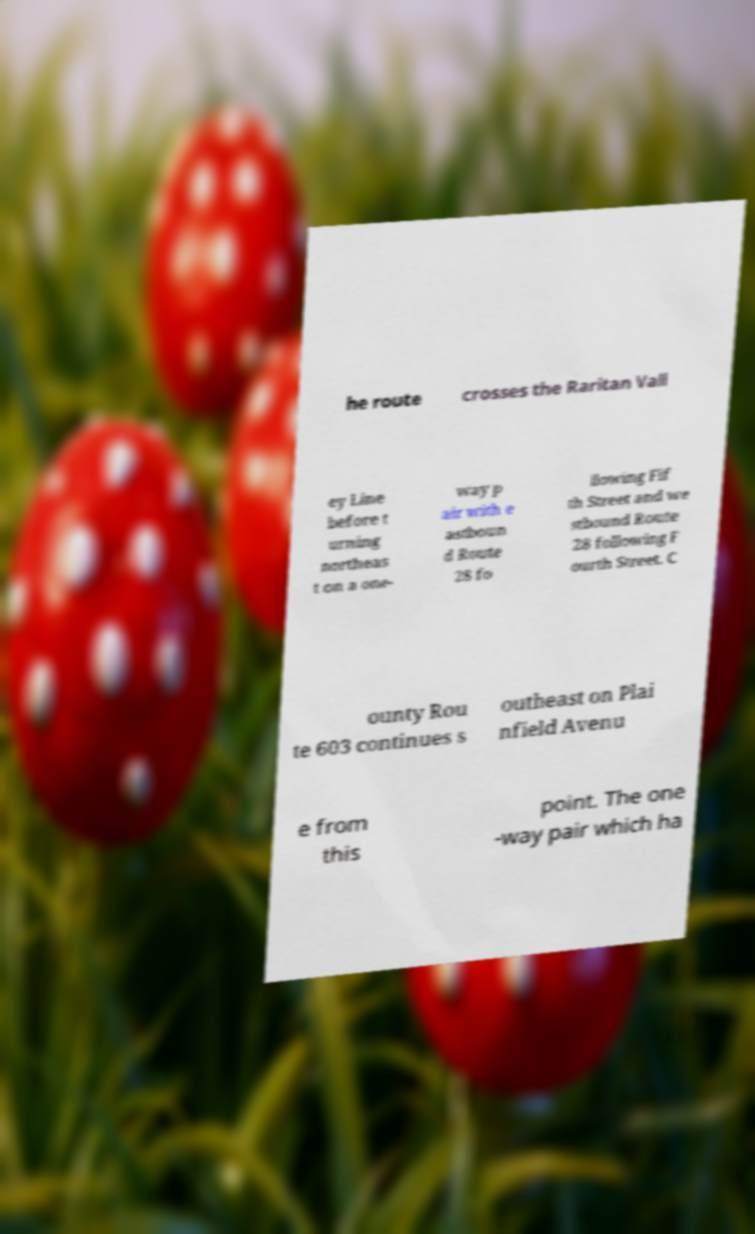Can you read and provide the text displayed in the image?This photo seems to have some interesting text. Can you extract and type it out for me? he route crosses the Raritan Vall ey Line before t urning northeas t on a one- way p air with e astboun d Route 28 fo llowing Fif th Street and we stbound Route 28 following F ourth Street. C ounty Rou te 603 continues s outheast on Plai nfield Avenu e from this point. The one -way pair which ha 